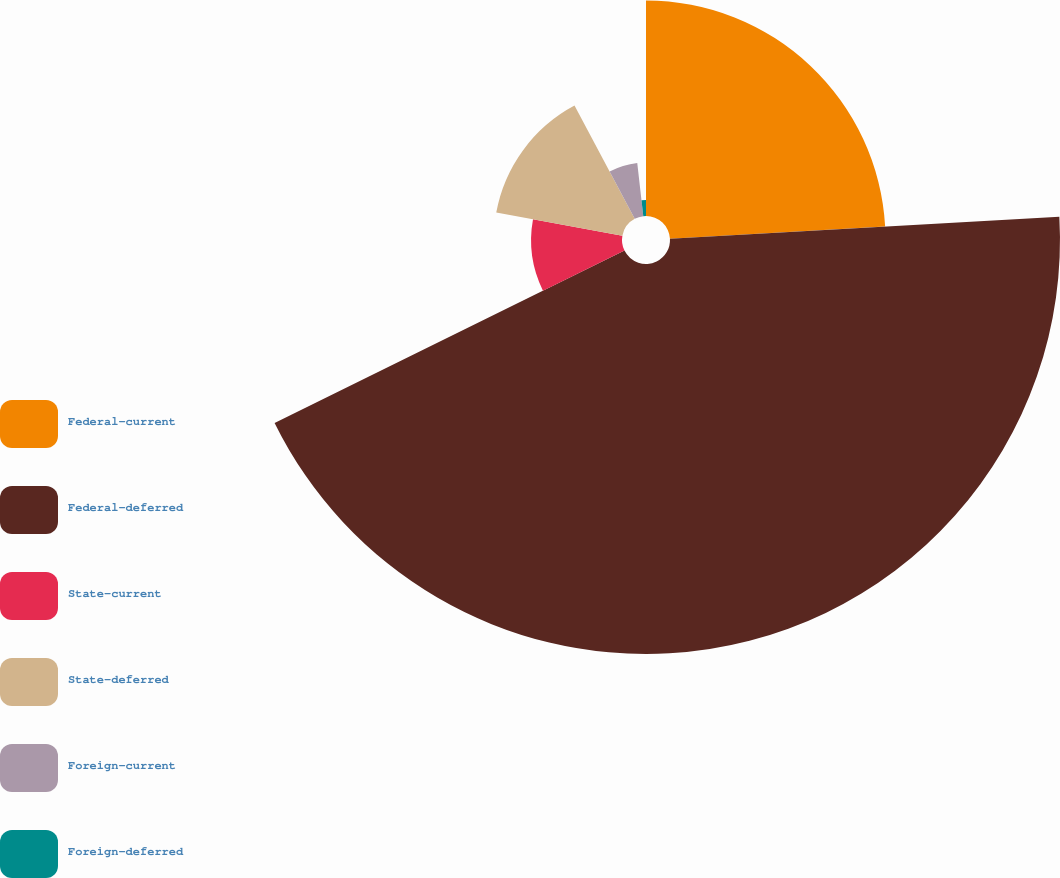<chart> <loc_0><loc_0><loc_500><loc_500><pie_chart><fcel>Federal-current<fcel>Federal-deferred<fcel>State-current<fcel>State-deferred<fcel>Foreign-current<fcel>Foreign-deferred<nl><fcel>24.1%<fcel>43.61%<fcel>10.16%<fcel>14.34%<fcel>5.98%<fcel>1.8%<nl></chart> 